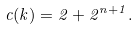<formula> <loc_0><loc_0><loc_500><loc_500>c ( k ) = 2 + 2 ^ { n + 1 } .</formula> 